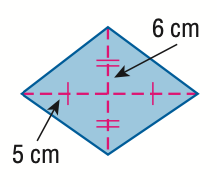Question: Find the area of the rhombus.
Choices:
A. 22
B. 30
C. 60
D. 120
Answer with the letter. Answer: C 